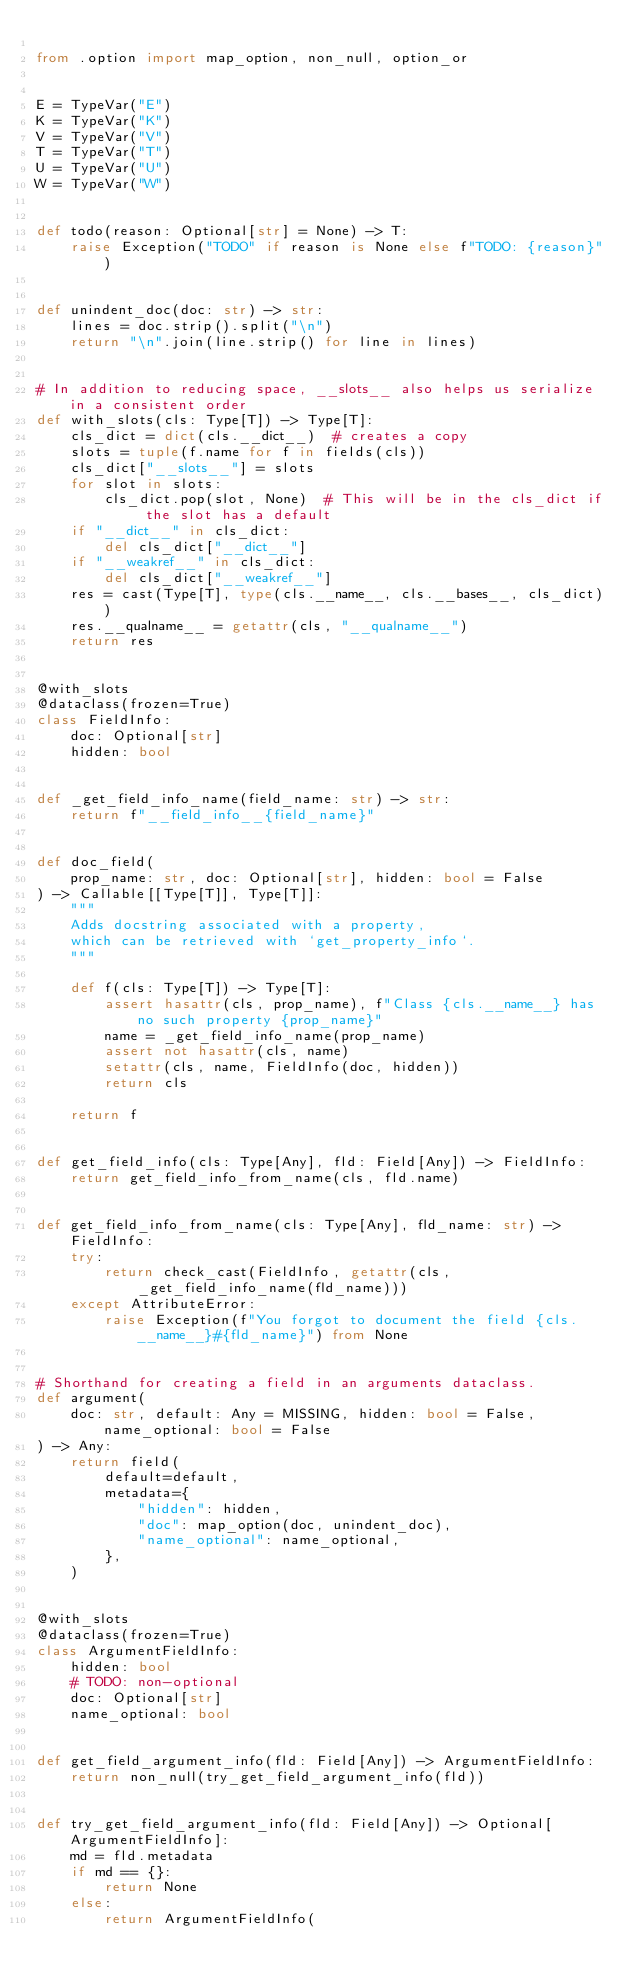<code> <loc_0><loc_0><loc_500><loc_500><_Python_>
from .option import map_option, non_null, option_or


E = TypeVar("E")
K = TypeVar("K")
V = TypeVar("V")
T = TypeVar("T")
U = TypeVar("U")
W = TypeVar("W")


def todo(reason: Optional[str] = None) -> T:
    raise Exception("TODO" if reason is None else f"TODO: {reason}")


def unindent_doc(doc: str) -> str:
    lines = doc.strip().split("\n")
    return "\n".join(line.strip() for line in lines)


# In addition to reducing space, __slots__ also helps us serialize in a consistent order
def with_slots(cls: Type[T]) -> Type[T]:
    cls_dict = dict(cls.__dict__)  # creates a copy
    slots = tuple(f.name for f in fields(cls))
    cls_dict["__slots__"] = slots
    for slot in slots:
        cls_dict.pop(slot, None)  # This will be in the cls_dict if the slot has a default
    if "__dict__" in cls_dict:
        del cls_dict["__dict__"]
    if "__weakref__" in cls_dict:
        del cls_dict["__weakref__"]
    res = cast(Type[T], type(cls.__name__, cls.__bases__, cls_dict))
    res.__qualname__ = getattr(cls, "__qualname__")
    return res


@with_slots
@dataclass(frozen=True)
class FieldInfo:
    doc: Optional[str]
    hidden: bool


def _get_field_info_name(field_name: str) -> str:
    return f"__field_info__{field_name}"


def doc_field(
    prop_name: str, doc: Optional[str], hidden: bool = False
) -> Callable[[Type[T]], Type[T]]:
    """
    Adds docstring associated with a property,
    which can be retrieved with `get_property_info`.
    """

    def f(cls: Type[T]) -> Type[T]:
        assert hasattr(cls, prop_name), f"Class {cls.__name__} has no such property {prop_name}"
        name = _get_field_info_name(prop_name)
        assert not hasattr(cls, name)
        setattr(cls, name, FieldInfo(doc, hidden))
        return cls

    return f


def get_field_info(cls: Type[Any], fld: Field[Any]) -> FieldInfo:
    return get_field_info_from_name(cls, fld.name)


def get_field_info_from_name(cls: Type[Any], fld_name: str) -> FieldInfo:
    try:
        return check_cast(FieldInfo, getattr(cls, _get_field_info_name(fld_name)))
    except AttributeError:
        raise Exception(f"You forgot to document the field {cls.__name__}#{fld_name}") from None


# Shorthand for creating a field in an arguments dataclass.
def argument(
    doc: str, default: Any = MISSING, hidden: bool = False, name_optional: bool = False
) -> Any:
    return field(
        default=default,
        metadata={
            "hidden": hidden,
            "doc": map_option(doc, unindent_doc),
            "name_optional": name_optional,
        },
    )


@with_slots
@dataclass(frozen=True)
class ArgumentFieldInfo:
    hidden: bool
    # TODO: non-optional
    doc: Optional[str]
    name_optional: bool


def get_field_argument_info(fld: Field[Any]) -> ArgumentFieldInfo:
    return non_null(try_get_field_argument_info(fld))


def try_get_field_argument_info(fld: Field[Any]) -> Optional[ArgumentFieldInfo]:
    md = fld.metadata
    if md == {}:
        return None
    else:
        return ArgumentFieldInfo(</code> 